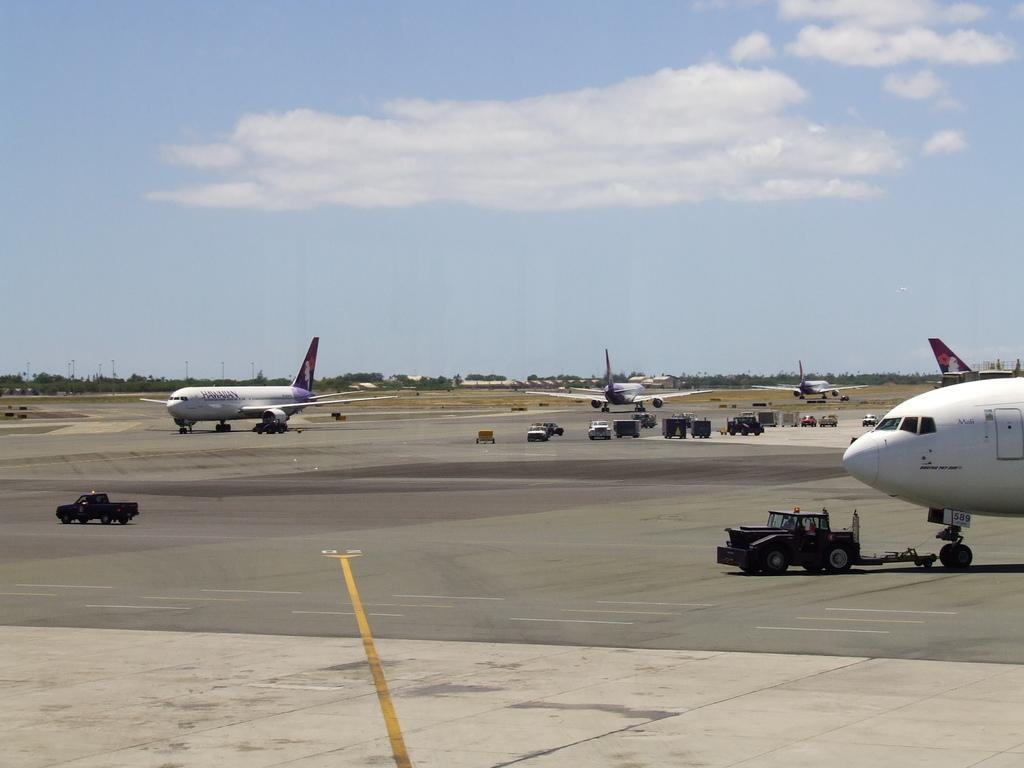Where was the image taken? The image was taken on a road. What can be seen on the road in the image? There are airplanes and vehicles parked on the road in the image. What is visible in the background of the image? There are trees and poles in the background of the image. What is visible at the top of the image? The sky is visible at the top of the image. What type of treatment is being administered to the airplanes in the image? There is no treatment being administered to the airplanes in the image; they are simply parked on the road. What type of apparel is being worn by the trees in the background? There is no apparel present in the image, as trees do not wear clothing. 